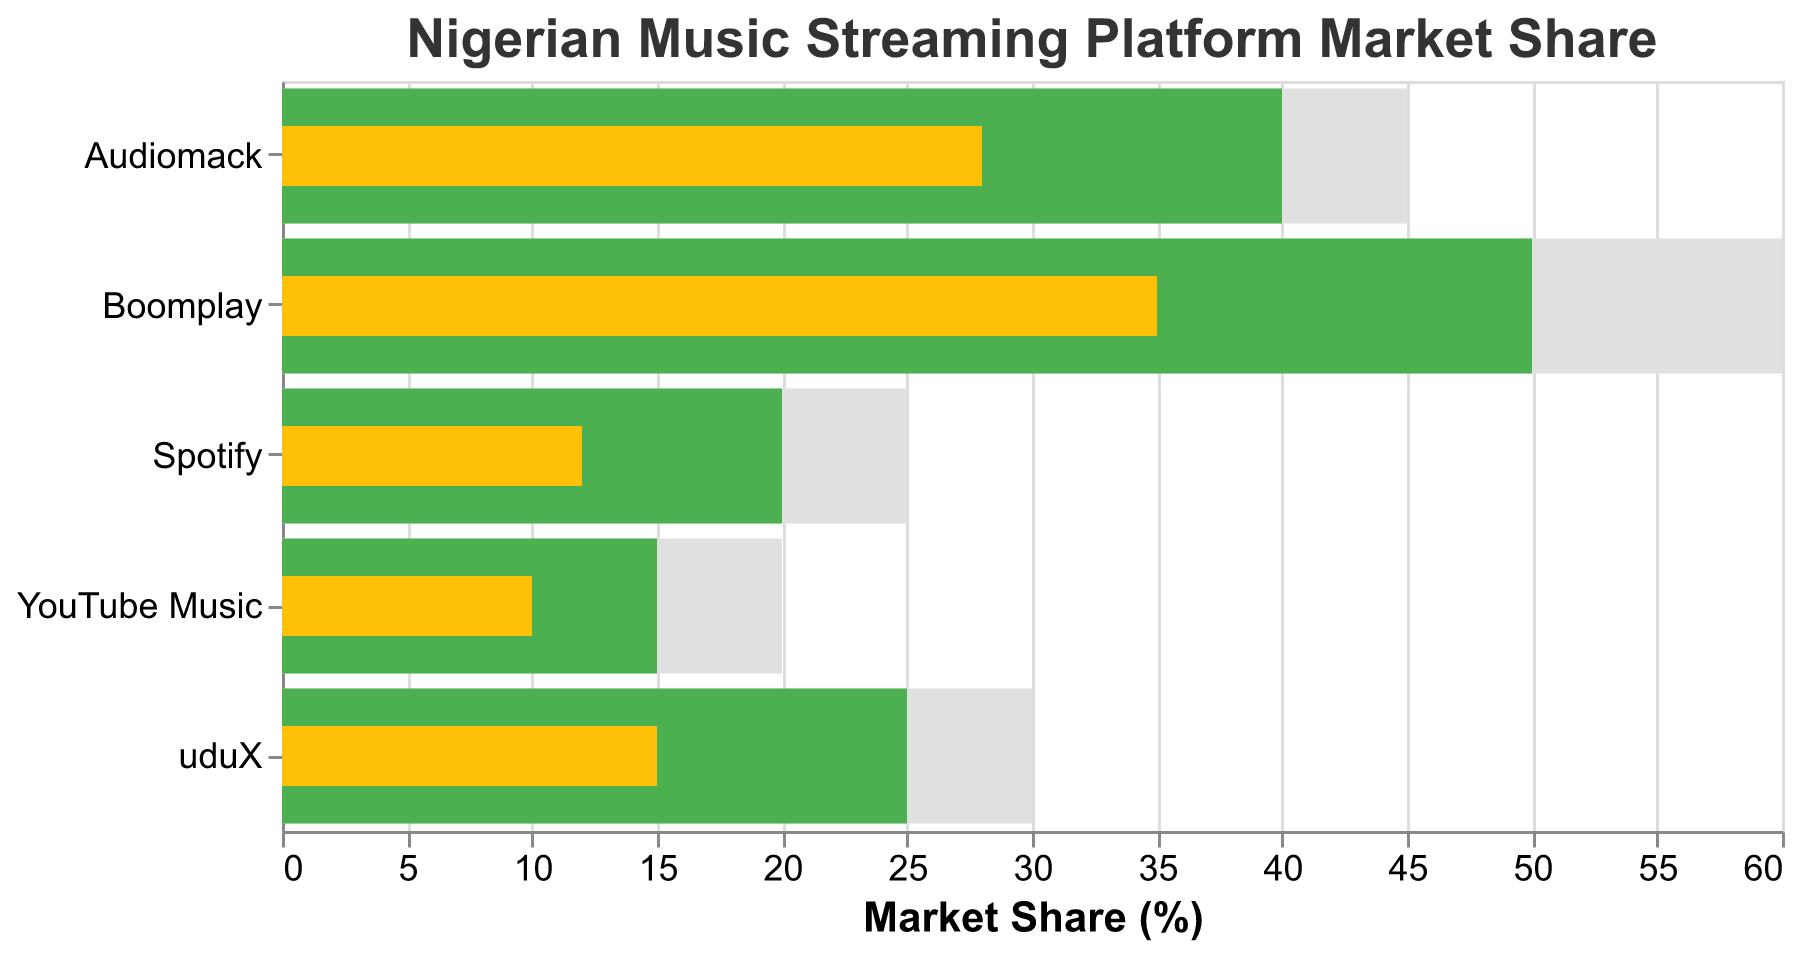What is the actual market share of Boomplay? The actual market share of Boomplay is displayed on the plot and colored in yellow. By looking at the figure, we can see that Boomplay's actual market share is 35%.
Answer: 35% How much lower is Audiomack's actual market share compared to its target? Audiomack's actual market share is 28%, and its target market share is 40%. The difference between the target and actual value can be calculated as 40% - 28% = 12%.
Answer: 12% Which platform has the highest comparative market share? By examining the longest gray bar representing the comparative market share, we can see that Boomplay has the highest comparative market share with 60%.
Answer: Boomplay What is the difference between uduX's comparative and target market share? uduX has a comparative market share of 30% and a target market share of 25%. The difference is calculated by subtracting the target from the comparative, which gives 30% - 25% = 5%.
Answer: 5% Which platform has the smallest actual market share, and what is the value? By looking at the shortest yellow bar, we can see that YouTube Music has the smallest actual market share, which is 10%.
Answer: YouTube Music, 10% Did any platform exceed its target market share? No platform's actual market share (yellow bar) exceeds its target market share (green bar). All actual market shares are below or equal to their targets.
Answer: No By how much does Spotify's comparative market share exceed its actual market share? Spotify has a comparative market share of 25% and an actual market share of 12%. The difference is calculated as 25% - 12% = 13%.
Answer: 13% Which platform fell the shortest from its target in terms of actual market share? By comparing the gaps between the yellow (actual) and green (target) bars of all platforms, we find that YouTube Music has the smallest difference between its actual market share (10%) and target market share (15%), which is 15% - 10% = 5%.
Answer: YouTube Music If you sum the actual market shares of uduX, Spotify, and YouTube Music, what is the total? The actual market shares for uduX, Spotify, and YouTube Music are 15%, 12%, and 10% respectively. Adding these together gives 15% + 12% + 10% = 37%.
Answer: 37% Is the target market share for any platform exactly equal to the comparative market share? By checking all pairs of target (green) and comparative (gray) bars, we see that no platform has a target market share exactly equal to its comparative market share.
Answer: No 